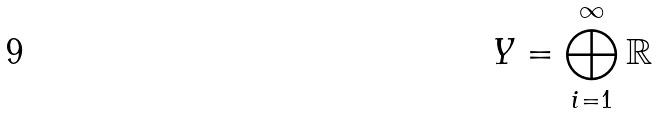<formula> <loc_0><loc_0><loc_500><loc_500>Y = \bigoplus _ { i = 1 } ^ { \infty } \mathbb { R }</formula> 